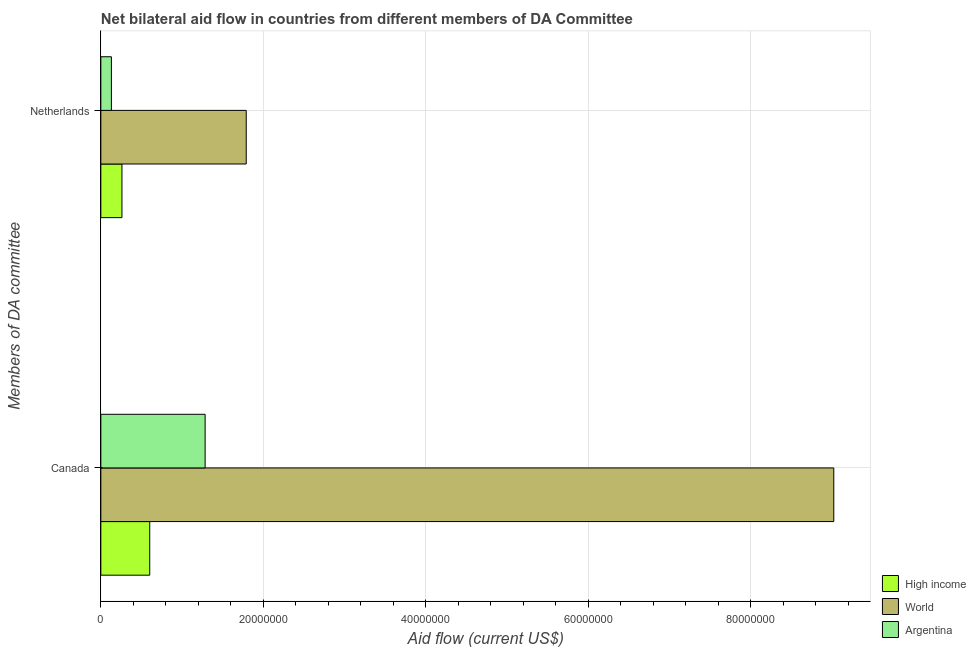How many groups of bars are there?
Give a very brief answer. 2. Are the number of bars on each tick of the Y-axis equal?
Offer a very short reply. Yes. What is the label of the 2nd group of bars from the top?
Your answer should be compact. Canada. What is the amount of aid given by canada in High income?
Ensure brevity in your answer.  6.02e+06. Across all countries, what is the maximum amount of aid given by netherlands?
Keep it short and to the point. 1.79e+07. Across all countries, what is the minimum amount of aid given by netherlands?
Your answer should be compact. 1.30e+06. In which country was the amount of aid given by netherlands minimum?
Your answer should be very brief. Argentina. What is the total amount of aid given by canada in the graph?
Your answer should be compact. 1.09e+08. What is the difference between the amount of aid given by netherlands in Argentina and that in World?
Provide a short and direct response. -1.66e+07. What is the difference between the amount of aid given by canada in Argentina and the amount of aid given by netherlands in High income?
Keep it short and to the point. 1.02e+07. What is the average amount of aid given by canada per country?
Your answer should be compact. 3.64e+07. What is the difference between the amount of aid given by netherlands and amount of aid given by canada in World?
Provide a short and direct response. -7.23e+07. In how many countries, is the amount of aid given by netherlands greater than 4000000 US$?
Provide a succinct answer. 1. What is the ratio of the amount of aid given by netherlands in High income to that in World?
Provide a short and direct response. 0.15. In how many countries, is the amount of aid given by canada greater than the average amount of aid given by canada taken over all countries?
Make the answer very short. 1. How many countries are there in the graph?
Give a very brief answer. 3. What is the difference between two consecutive major ticks on the X-axis?
Your response must be concise. 2.00e+07. Where does the legend appear in the graph?
Provide a short and direct response. Bottom right. How many legend labels are there?
Give a very brief answer. 3. What is the title of the graph?
Give a very brief answer. Net bilateral aid flow in countries from different members of DA Committee. Does "Mexico" appear as one of the legend labels in the graph?
Keep it short and to the point. No. What is the label or title of the X-axis?
Keep it short and to the point. Aid flow (current US$). What is the label or title of the Y-axis?
Your response must be concise. Members of DA committee. What is the Aid flow (current US$) of High income in Canada?
Offer a terse response. 6.02e+06. What is the Aid flow (current US$) in World in Canada?
Your answer should be very brief. 9.02e+07. What is the Aid flow (current US$) in Argentina in Canada?
Your answer should be very brief. 1.28e+07. What is the Aid flow (current US$) in High income in Netherlands?
Offer a terse response. 2.60e+06. What is the Aid flow (current US$) in World in Netherlands?
Your answer should be very brief. 1.79e+07. What is the Aid flow (current US$) in Argentina in Netherlands?
Give a very brief answer. 1.30e+06. Across all Members of DA committee, what is the maximum Aid flow (current US$) in High income?
Provide a short and direct response. 6.02e+06. Across all Members of DA committee, what is the maximum Aid flow (current US$) in World?
Your answer should be very brief. 9.02e+07. Across all Members of DA committee, what is the maximum Aid flow (current US$) in Argentina?
Keep it short and to the point. 1.28e+07. Across all Members of DA committee, what is the minimum Aid flow (current US$) of High income?
Provide a short and direct response. 2.60e+06. Across all Members of DA committee, what is the minimum Aid flow (current US$) in World?
Offer a terse response. 1.79e+07. Across all Members of DA committee, what is the minimum Aid flow (current US$) of Argentina?
Your response must be concise. 1.30e+06. What is the total Aid flow (current US$) in High income in the graph?
Your answer should be very brief. 8.62e+06. What is the total Aid flow (current US$) in World in the graph?
Your answer should be compact. 1.08e+08. What is the total Aid flow (current US$) in Argentina in the graph?
Your response must be concise. 1.41e+07. What is the difference between the Aid flow (current US$) of High income in Canada and that in Netherlands?
Your response must be concise. 3.42e+06. What is the difference between the Aid flow (current US$) of World in Canada and that in Netherlands?
Provide a succinct answer. 7.23e+07. What is the difference between the Aid flow (current US$) of Argentina in Canada and that in Netherlands?
Offer a very short reply. 1.15e+07. What is the difference between the Aid flow (current US$) in High income in Canada and the Aid flow (current US$) in World in Netherlands?
Provide a short and direct response. -1.19e+07. What is the difference between the Aid flow (current US$) in High income in Canada and the Aid flow (current US$) in Argentina in Netherlands?
Ensure brevity in your answer.  4.72e+06. What is the difference between the Aid flow (current US$) of World in Canada and the Aid flow (current US$) of Argentina in Netherlands?
Keep it short and to the point. 8.89e+07. What is the average Aid flow (current US$) of High income per Members of DA committee?
Your answer should be compact. 4.31e+06. What is the average Aid flow (current US$) of World per Members of DA committee?
Offer a very short reply. 5.41e+07. What is the average Aid flow (current US$) of Argentina per Members of DA committee?
Give a very brief answer. 7.07e+06. What is the difference between the Aid flow (current US$) of High income and Aid flow (current US$) of World in Canada?
Your response must be concise. -8.42e+07. What is the difference between the Aid flow (current US$) of High income and Aid flow (current US$) of Argentina in Canada?
Your answer should be compact. -6.82e+06. What is the difference between the Aid flow (current US$) in World and Aid flow (current US$) in Argentina in Canada?
Ensure brevity in your answer.  7.74e+07. What is the difference between the Aid flow (current US$) in High income and Aid flow (current US$) in World in Netherlands?
Give a very brief answer. -1.53e+07. What is the difference between the Aid flow (current US$) in High income and Aid flow (current US$) in Argentina in Netherlands?
Your answer should be compact. 1.30e+06. What is the difference between the Aid flow (current US$) of World and Aid flow (current US$) of Argentina in Netherlands?
Your answer should be compact. 1.66e+07. What is the ratio of the Aid flow (current US$) of High income in Canada to that in Netherlands?
Ensure brevity in your answer.  2.32. What is the ratio of the Aid flow (current US$) in World in Canada to that in Netherlands?
Keep it short and to the point. 5.04. What is the ratio of the Aid flow (current US$) in Argentina in Canada to that in Netherlands?
Keep it short and to the point. 9.88. What is the difference between the highest and the second highest Aid flow (current US$) of High income?
Offer a very short reply. 3.42e+06. What is the difference between the highest and the second highest Aid flow (current US$) of World?
Your response must be concise. 7.23e+07. What is the difference between the highest and the second highest Aid flow (current US$) in Argentina?
Your answer should be very brief. 1.15e+07. What is the difference between the highest and the lowest Aid flow (current US$) of High income?
Make the answer very short. 3.42e+06. What is the difference between the highest and the lowest Aid flow (current US$) of World?
Give a very brief answer. 7.23e+07. What is the difference between the highest and the lowest Aid flow (current US$) of Argentina?
Provide a succinct answer. 1.15e+07. 